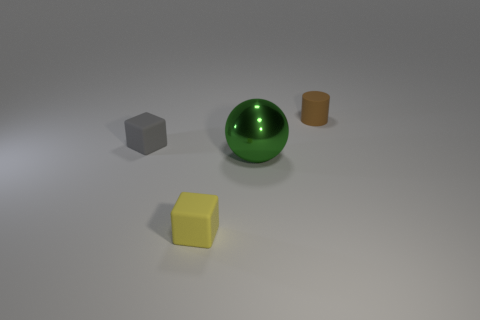Can you tell me what materials these objects seem to be made of? The objects appear to be made of various materials. The sphere has a reflective surface suggesting it is likely metallic, the gray cube seems to be made of rubber due to its matte finish, and the yellow cube looks like it could be a plastic material due to its slight sheen. The cylindrical object has an even matte finish which might indicate a clay or an unglazed ceramic material. 